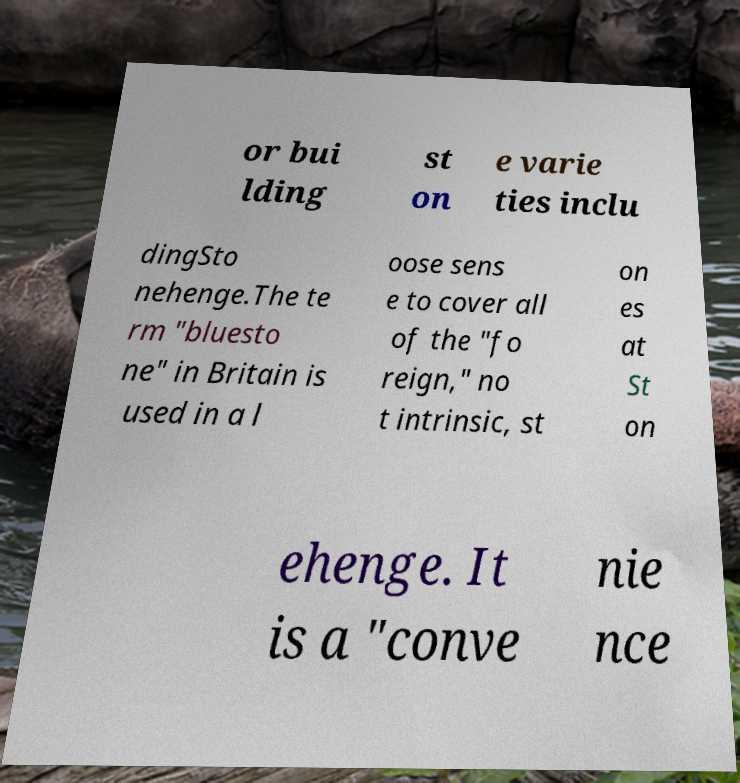For documentation purposes, I need the text within this image transcribed. Could you provide that? or bui lding st on e varie ties inclu dingSto nehenge.The te rm "bluesto ne" in Britain is used in a l oose sens e to cover all of the "fo reign," no t intrinsic, st on es at St on ehenge. It is a "conve nie nce 